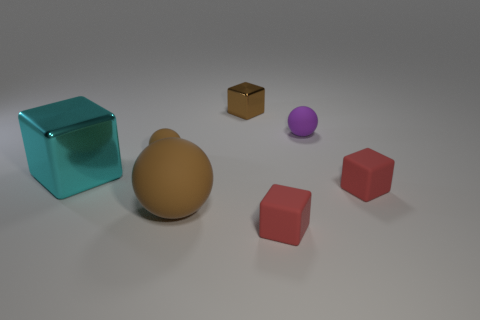Subtract all balls. How many objects are left? 4 Add 2 tiny red cubes. How many objects exist? 9 Subtract all cyan blocks. How many blocks are left? 3 Subtract all purple balls. How many balls are left? 2 Subtract 3 spheres. How many spheres are left? 0 Subtract all big rubber things. Subtract all large brown rubber objects. How many objects are left? 5 Add 5 tiny red matte cubes. How many tiny red matte cubes are left? 7 Add 3 small cyan matte balls. How many small cyan matte balls exist? 3 Subtract 0 gray blocks. How many objects are left? 7 Subtract all gray blocks. Subtract all purple balls. How many blocks are left? 4 